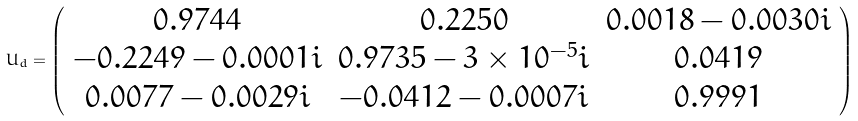Convert formula to latex. <formula><loc_0><loc_0><loc_500><loc_500>U _ { d } = \left ( \begin{array} { c c c } 0 . 9 7 4 4 & 0 . 2 2 5 0 & 0 . 0 0 1 8 - 0 . 0 0 3 0 i \\ - 0 . 2 2 4 9 - 0 . 0 0 0 1 i & 0 . 9 7 3 5 - 3 \times 1 0 ^ { - 5 } i & 0 . 0 4 1 9 \\ 0 . 0 0 7 7 - 0 . 0 0 2 9 i & - 0 . 0 4 1 2 - 0 . 0 0 0 7 i & 0 . 9 9 9 1 \end{array} \right )</formula> 